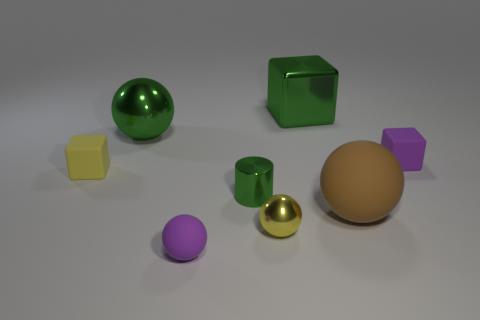Subtract all green blocks. How many blocks are left? 2 Add 1 tiny brown metallic cylinders. How many objects exist? 9 Subtract all yellow spheres. How many spheres are left? 3 Subtract all blocks. How many objects are left? 5 Subtract 1 blocks. How many blocks are left? 2 Subtract all brown spheres. Subtract all red cylinders. How many spheres are left? 3 Add 6 large green rubber balls. How many large green rubber balls exist? 6 Subtract 0 cyan cylinders. How many objects are left? 8 Subtract all big brown balls. Subtract all large brown things. How many objects are left? 6 Add 2 large brown matte objects. How many large brown matte objects are left? 3 